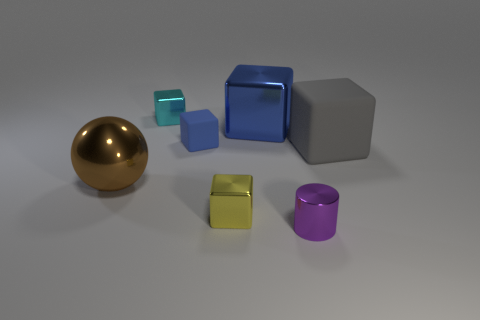What number of spheres are cyan things or gray rubber objects?
Offer a terse response. 0. What number of other objects are there of the same material as the small purple cylinder?
Your answer should be compact. 4. The small thing that is in front of the yellow metallic block has what shape?
Offer a terse response. Cylinder. What material is the large object that is behind the rubber cube that is on the right side of the purple shiny cylinder made of?
Your answer should be very brief. Metal. Is the number of small cyan metal cubes that are in front of the gray object greater than the number of big brown balls?
Provide a succinct answer. No. What number of other things are the same color as the metal sphere?
Your answer should be very brief. 0. There is a cyan object that is the same size as the yellow thing; what is its shape?
Keep it short and to the point. Cube. How many spheres are behind the thing to the left of the cube on the left side of the blue rubber cube?
Give a very brief answer. 0. What number of rubber objects are either tiny purple things or gray things?
Offer a terse response. 1. There is a small shiny object that is behind the purple thing and right of the cyan metallic cube; what is its color?
Offer a terse response. Yellow. 